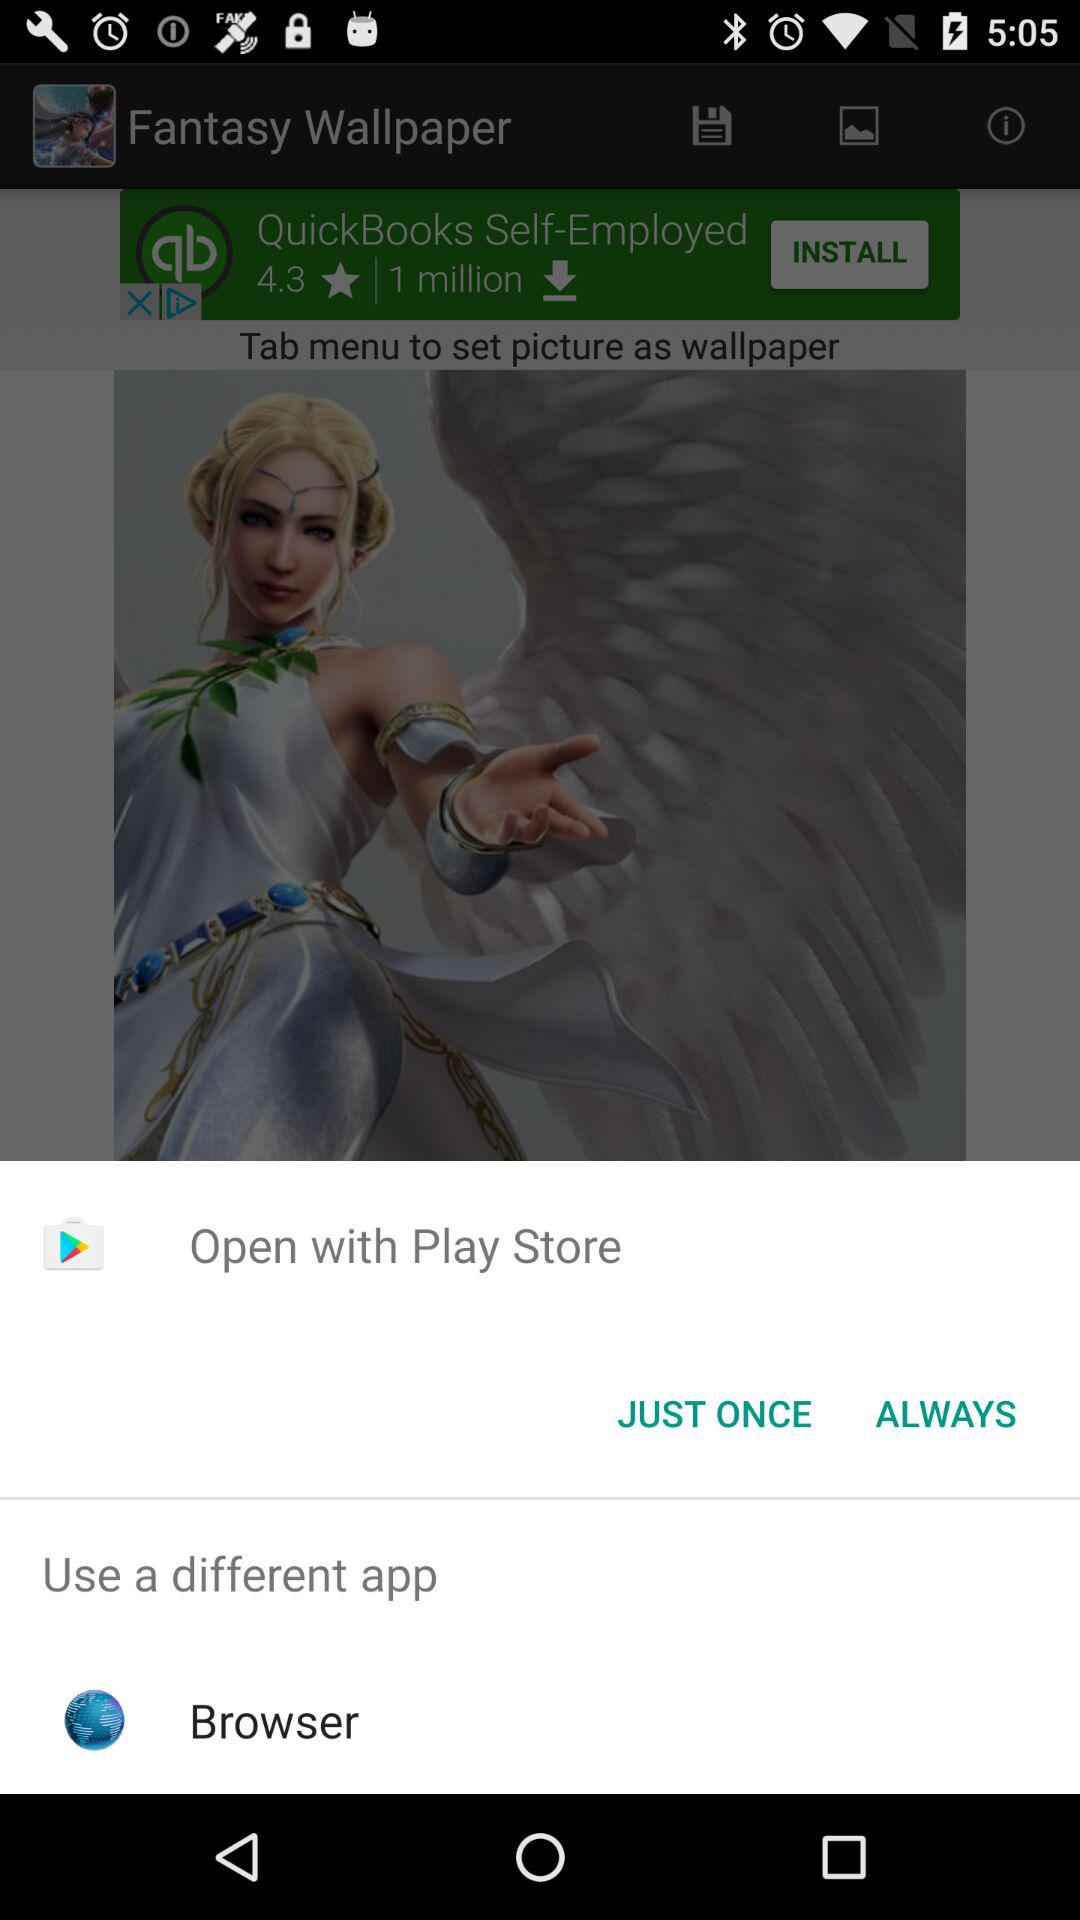Through what service can we open the application? You can open the application with "Play Store" and "Browser". 